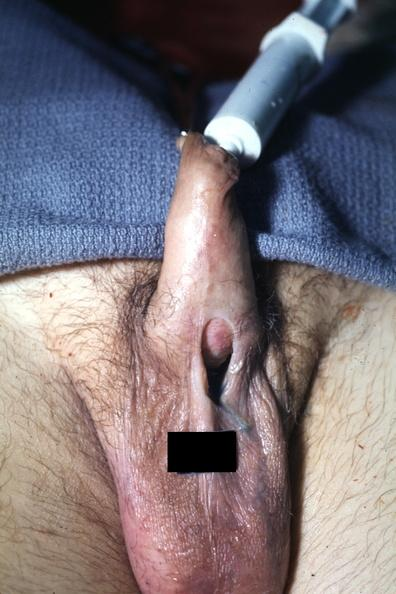s slices of liver and spleen typical tuberculous exudate is present on capsule of liver and spleen present?
Answer the question using a single word or phrase. No 